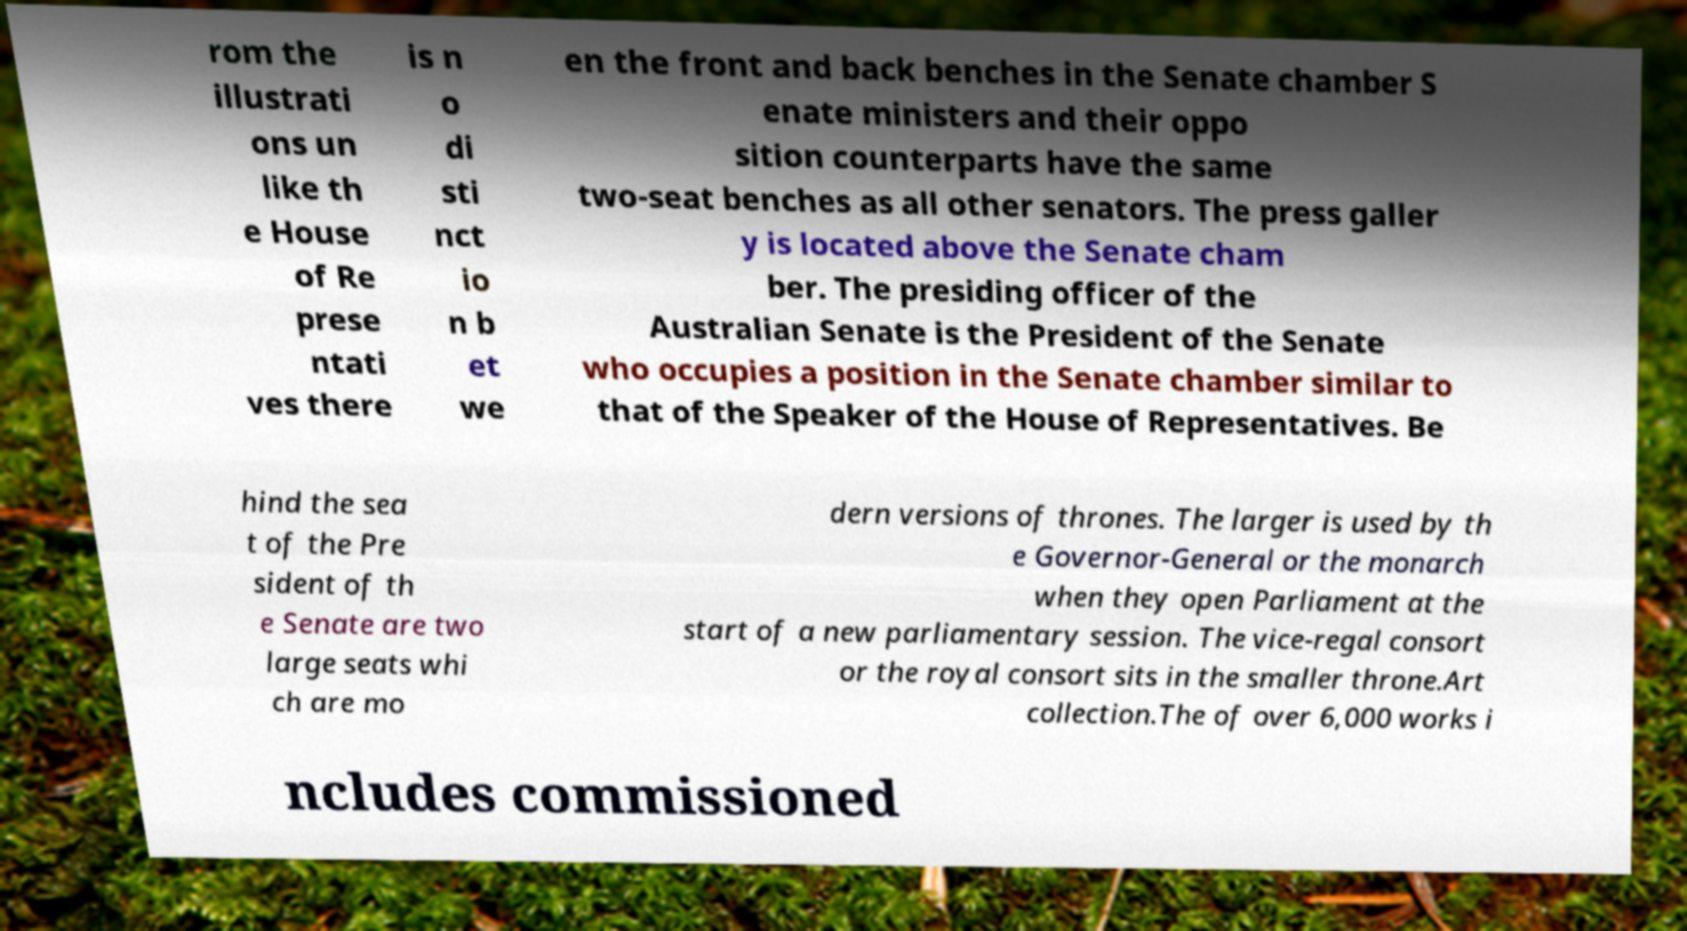Can you read and provide the text displayed in the image?This photo seems to have some interesting text. Can you extract and type it out for me? rom the illustrati ons un like th e House of Re prese ntati ves there is n o di sti nct io n b et we en the front and back benches in the Senate chamber S enate ministers and their oppo sition counterparts have the same two-seat benches as all other senators. The press galler y is located above the Senate cham ber. The presiding officer of the Australian Senate is the President of the Senate who occupies a position in the Senate chamber similar to that of the Speaker of the House of Representatives. Be hind the sea t of the Pre sident of th e Senate are two large seats whi ch are mo dern versions of thrones. The larger is used by th e Governor-General or the monarch when they open Parliament at the start of a new parliamentary session. The vice-regal consort or the royal consort sits in the smaller throne.Art collection.The of over 6,000 works i ncludes commissioned 